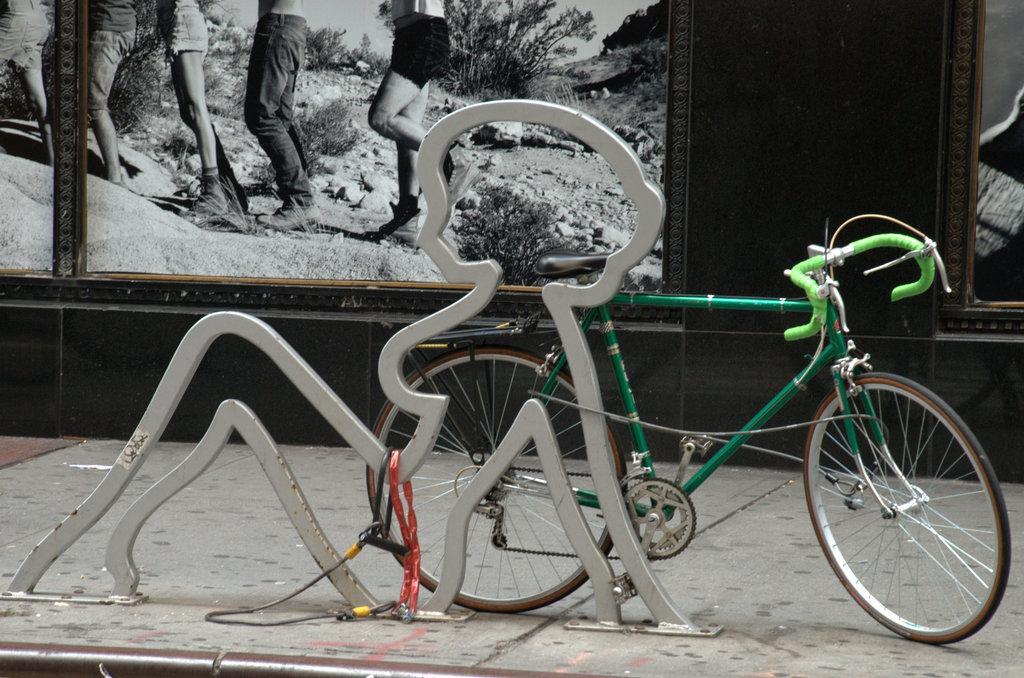Can you describe this image briefly? In the center of the image we can see a bicycle and iron frame are present. At the top of the image photo frame is there. At the bottom of the image ground is there. 